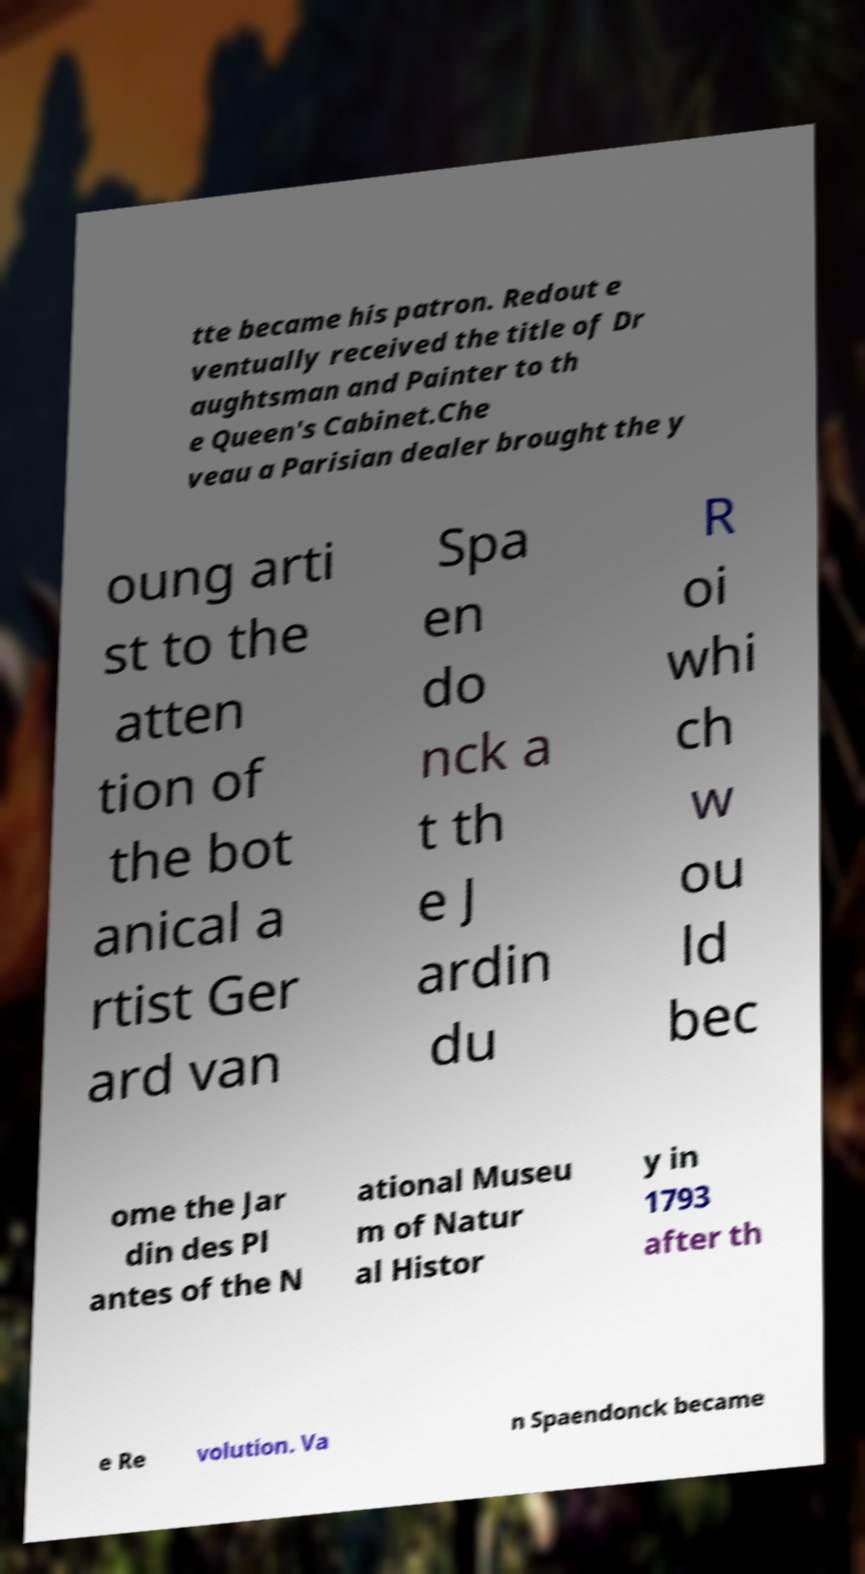There's text embedded in this image that I need extracted. Can you transcribe it verbatim? tte became his patron. Redout e ventually received the title of Dr aughtsman and Painter to th e Queen's Cabinet.Che veau a Parisian dealer brought the y oung arti st to the atten tion of the bot anical a rtist Ger ard van Spa en do nck a t th e J ardin du R oi whi ch w ou ld bec ome the Jar din des Pl antes of the N ational Museu m of Natur al Histor y in 1793 after th e Re volution. Va n Spaendonck became 